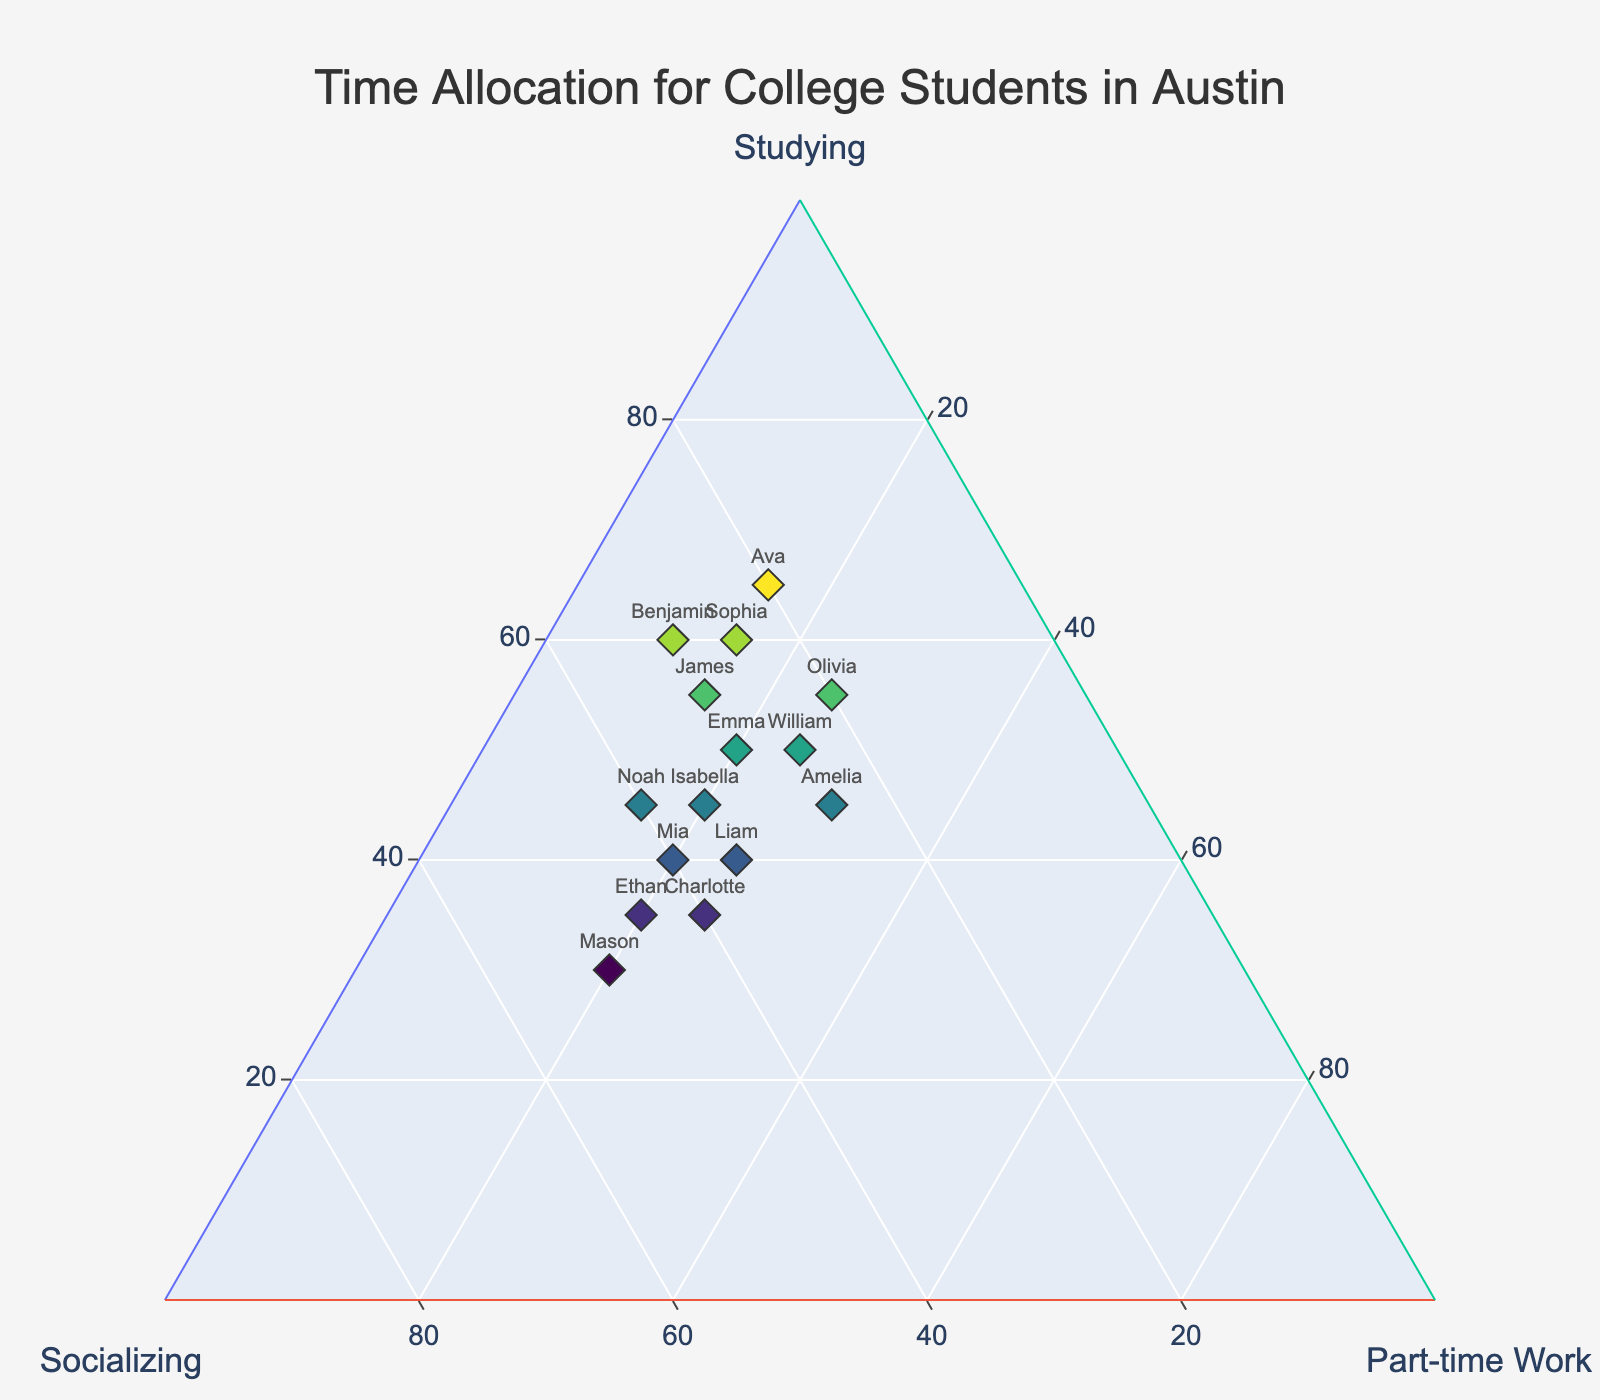What's the title of the ternary plot? The title is typically placed at the top of the figure. In this case, the title is "Time Allocation for College Students in Austin" as explicitly stated in the provided code.
Answer: Time Allocation for College Students in Austin What are the labels of the three axes? The axes labels are typically shown next to each axis. In this plot, they are 'Studying', 'Socializing', and 'Part-time Work' as defined in the code.
Answer: Studying, Socializing, Part-time Work Which student allocates the most time to studying? To find this, observe the data points and their labels. The student who allocates the most time to studying is near the 'Studying' axis. Ava spends 65% for studying, the highest among all students.
Answer: Ava Which student puts the least amount of time into part-time work? Check the data points closest to the 'Part-time Work' axis. Benjamin commits only 10% to part-time work, the lowest value in the dataset.
Answer: Benjamin How many students spend exactly 20% of their time socializing? Look for data points where the 'Socializing' component equals 20%. According to the table, Ava, Olivia, and Sophia each spend 20% of their time socializing.
Answer: 3 Comparing Ethan and Mason, who spends more time socializing? Ethan is observed at 45% for socializing, while Mason is at 50%. Thus, Mason spends more time socializing.
Answer: Mason What is the combined total percentage for Olivia in studying and part-time work? Olivia spends 55% studying and 25% in part-time work. Adding these gives 55 + 25 = 80%.
Answer: 80% Find the student whose time allocation is closest to 50% studying, 25% socializing, and 25% part-time work. Examine the data where these values are closest. William allocates 50% to studying, 25% to socializing, and 25% to part-time work, matching these percentages exactly.
Answer: William Which student is closest to having a balanced allocation of time across studying, socializing, and part-time work? A balanced allocation would mean values close to 33% for each activity. Charlotte spends 35% studying, 40% socializing, and 25% part-time work, which is the closest to balanced among all students.
Answer: Charlotte 